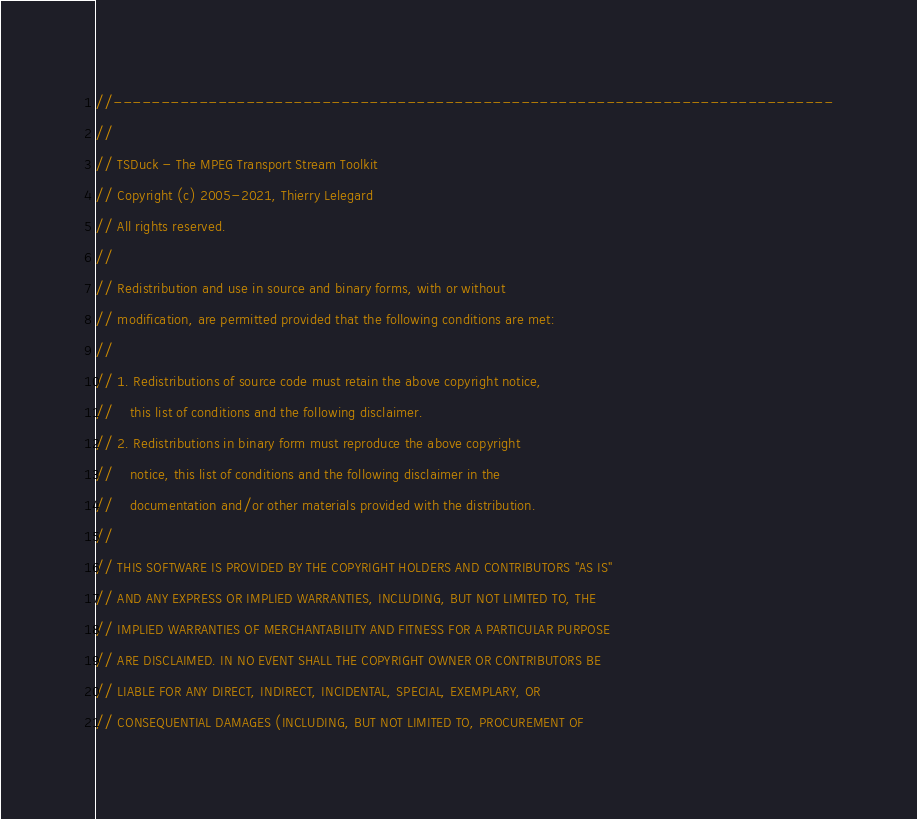Convert code to text. <code><loc_0><loc_0><loc_500><loc_500><_C++_>//----------------------------------------------------------------------------
//
// TSDuck - The MPEG Transport Stream Toolkit
// Copyright (c) 2005-2021, Thierry Lelegard
// All rights reserved.
//
// Redistribution and use in source and binary forms, with or without
// modification, are permitted provided that the following conditions are met:
//
// 1. Redistributions of source code must retain the above copyright notice,
//    this list of conditions and the following disclaimer.
// 2. Redistributions in binary form must reproduce the above copyright
//    notice, this list of conditions and the following disclaimer in the
//    documentation and/or other materials provided with the distribution.
//
// THIS SOFTWARE IS PROVIDED BY THE COPYRIGHT HOLDERS AND CONTRIBUTORS "AS IS"
// AND ANY EXPRESS OR IMPLIED WARRANTIES, INCLUDING, BUT NOT LIMITED TO, THE
// IMPLIED WARRANTIES OF MERCHANTABILITY AND FITNESS FOR A PARTICULAR PURPOSE
// ARE DISCLAIMED. IN NO EVENT SHALL THE COPYRIGHT OWNER OR CONTRIBUTORS BE
// LIABLE FOR ANY DIRECT, INDIRECT, INCIDENTAL, SPECIAL, EXEMPLARY, OR
// CONSEQUENTIAL DAMAGES (INCLUDING, BUT NOT LIMITED TO, PROCUREMENT OF</code> 